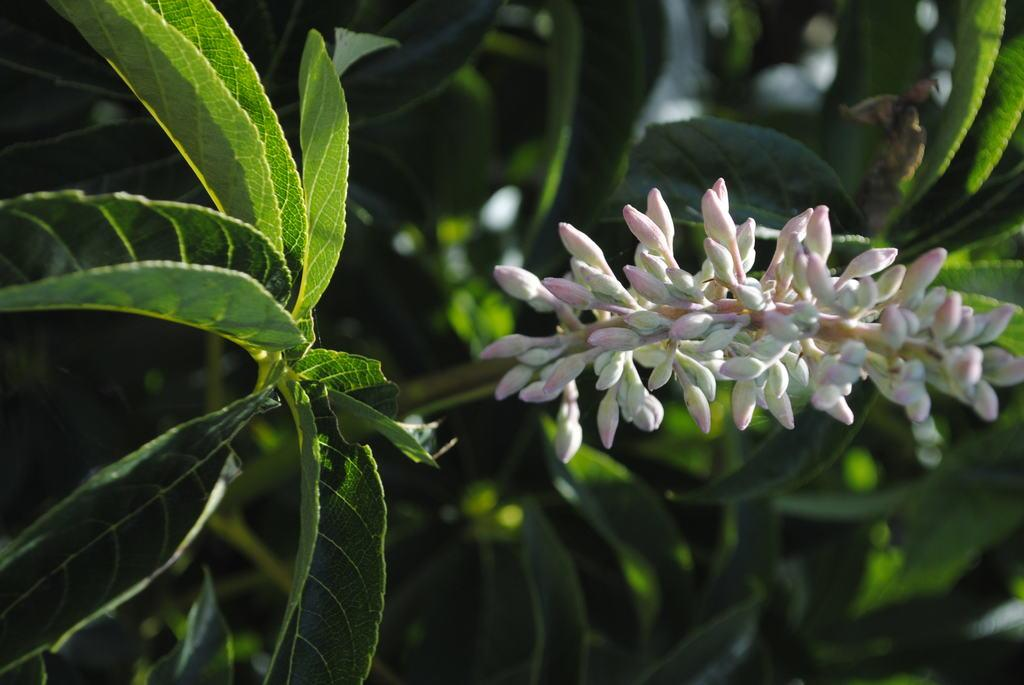Where was the image taken? The image was taken outdoors. What type of tree can be seen in the image? There is a tree with green leaves in the image. Are there any other plants visible in the image? Yes, there are plants in the image. What type of spoon is being used to dig the hill in the image? There is no spoon or hill present in the image; it features a tree with green leaves and other plants. 